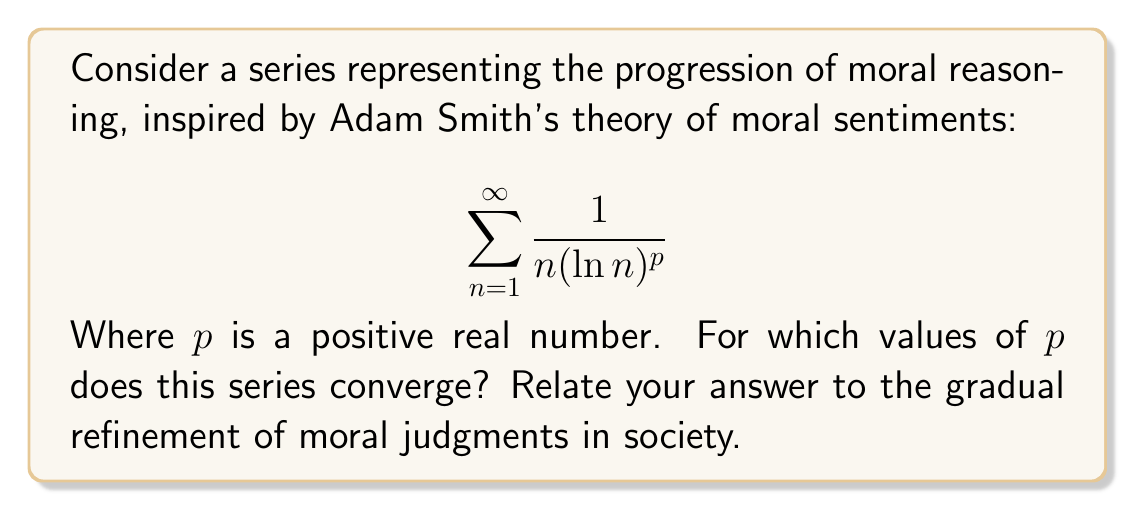Provide a solution to this math problem. To analyze the convergence of this series, we'll use the integral test:

1) First, let's define $f(x) = \frac{1}{x(\ln x)^p}$ for $x \geq 2$.

2) The integral test states that if $\int_2^{\infty} f(x)dx$ converges, then the series converges.

3) Let's evaluate the integral:

   $$\int_2^{\infty} \frac{1}{x(\ln x)^p}dx$$

4) Substitute $u = \ln x$, $du = \frac{1}{x}dx$:

   $$\int_{\ln 2}^{\infty} \frac{1}{u^p}du$$

5) Evaluate:

   $$\left[-\frac{1}{(p-1)u^{p-1}}\right]_{\ln 2}^{\infty}$$

6) This evaluates to:

   $$\lim_{t \to \infty} \left(-\frac{1}{(p-1)t^{p-1}} + \frac{1}{(p-1)(\ln 2)^{p-1}}\right)$$

7) This limit exists (converges) if and only if $p > 1$.

Relating to Smith's moral philosophy:
- When $p > 1$, the series converges, suggesting a stabilizing progression of moral reasoning in society.
- When $p \leq 1$, the series diverges, which could represent an ever-expanding scope of moral considerations.

The convergence for $p > 1$ aligns with Smith's idea that societies tend towards more refined and stable moral judgments over time, while still allowing for ongoing development.
Answer: The series converges for $p > 1$. 